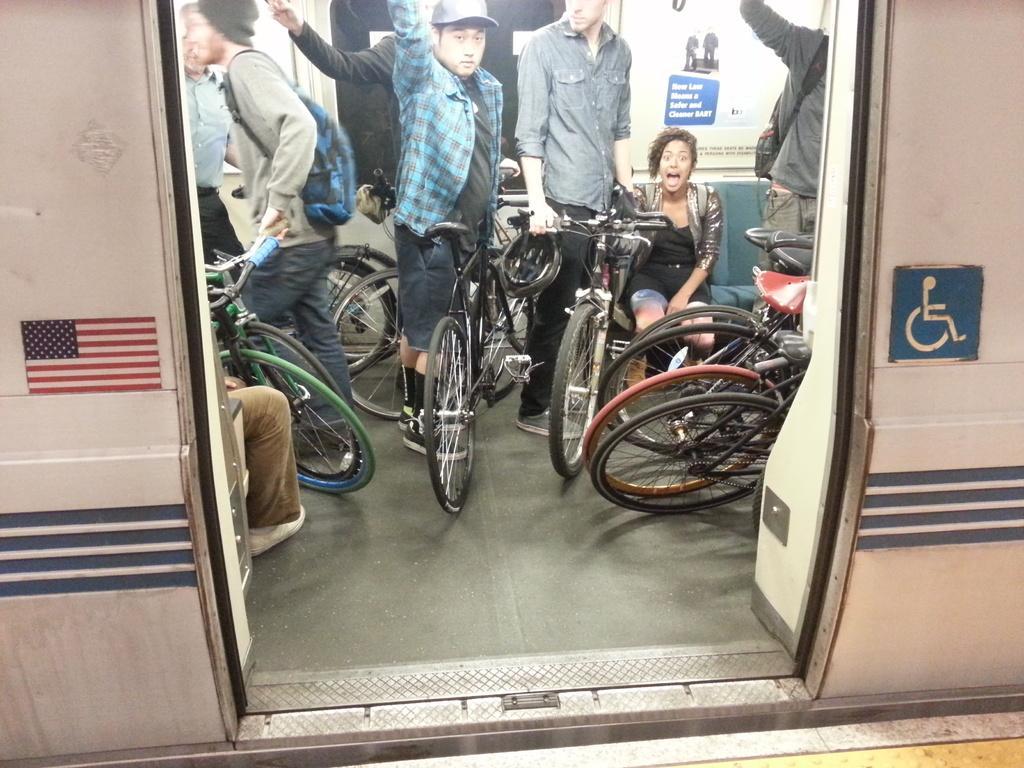Could you give a brief overview of what you see in this image? The picture is clicked inside a train where there are people standing with their bicycles in their hands and there is a woman sitting on a a sofa at the right side of the image. 